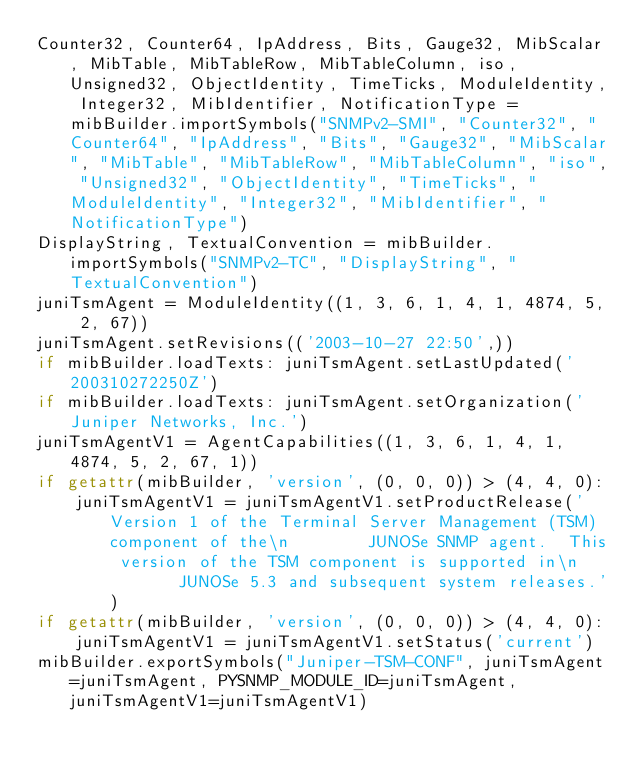<code> <loc_0><loc_0><loc_500><loc_500><_Python_>Counter32, Counter64, IpAddress, Bits, Gauge32, MibScalar, MibTable, MibTableRow, MibTableColumn, iso, Unsigned32, ObjectIdentity, TimeTicks, ModuleIdentity, Integer32, MibIdentifier, NotificationType = mibBuilder.importSymbols("SNMPv2-SMI", "Counter32", "Counter64", "IpAddress", "Bits", "Gauge32", "MibScalar", "MibTable", "MibTableRow", "MibTableColumn", "iso", "Unsigned32", "ObjectIdentity", "TimeTicks", "ModuleIdentity", "Integer32", "MibIdentifier", "NotificationType")
DisplayString, TextualConvention = mibBuilder.importSymbols("SNMPv2-TC", "DisplayString", "TextualConvention")
juniTsmAgent = ModuleIdentity((1, 3, 6, 1, 4, 1, 4874, 5, 2, 67))
juniTsmAgent.setRevisions(('2003-10-27 22:50',))
if mibBuilder.loadTexts: juniTsmAgent.setLastUpdated('200310272250Z')
if mibBuilder.loadTexts: juniTsmAgent.setOrganization('Juniper Networks, Inc.')
juniTsmAgentV1 = AgentCapabilities((1, 3, 6, 1, 4, 1, 4874, 5, 2, 67, 1))
if getattr(mibBuilder, 'version', (0, 0, 0)) > (4, 4, 0):
    juniTsmAgentV1 = juniTsmAgentV1.setProductRelease('Version 1 of the Terminal Server Management (TSM) component of the\n        JUNOSe SNMP agent.  This version of the TSM component is supported in\n        JUNOSe 5.3 and subsequent system releases.')
if getattr(mibBuilder, 'version', (0, 0, 0)) > (4, 4, 0):
    juniTsmAgentV1 = juniTsmAgentV1.setStatus('current')
mibBuilder.exportSymbols("Juniper-TSM-CONF", juniTsmAgent=juniTsmAgent, PYSNMP_MODULE_ID=juniTsmAgent, juniTsmAgentV1=juniTsmAgentV1)
</code> 